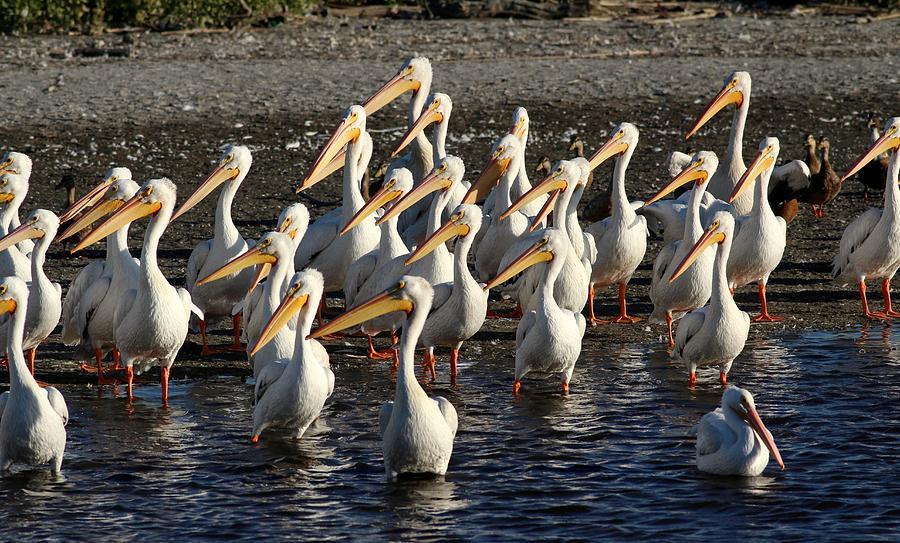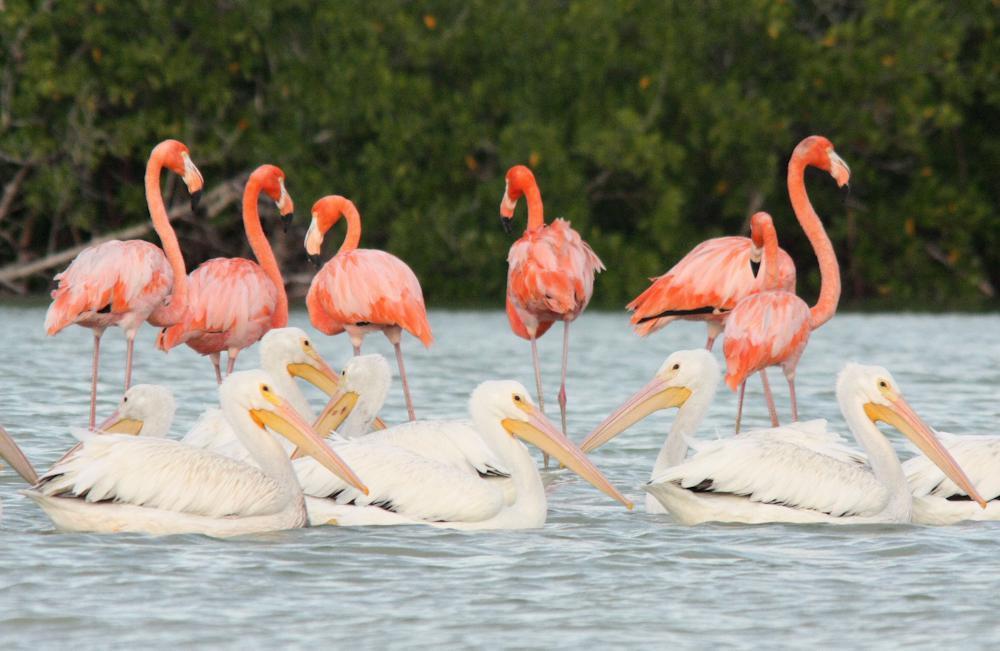The first image is the image on the left, the second image is the image on the right. Evaluate the accuracy of this statement regarding the images: "There are at most 5 birds in each image.". Is it true? Answer yes or no. No. The first image is the image on the left, the second image is the image on the right. Evaluate the accuracy of this statement regarding the images: "Right image shows pelicans with smaller dark birds.". Is it true? Answer yes or no. No. 